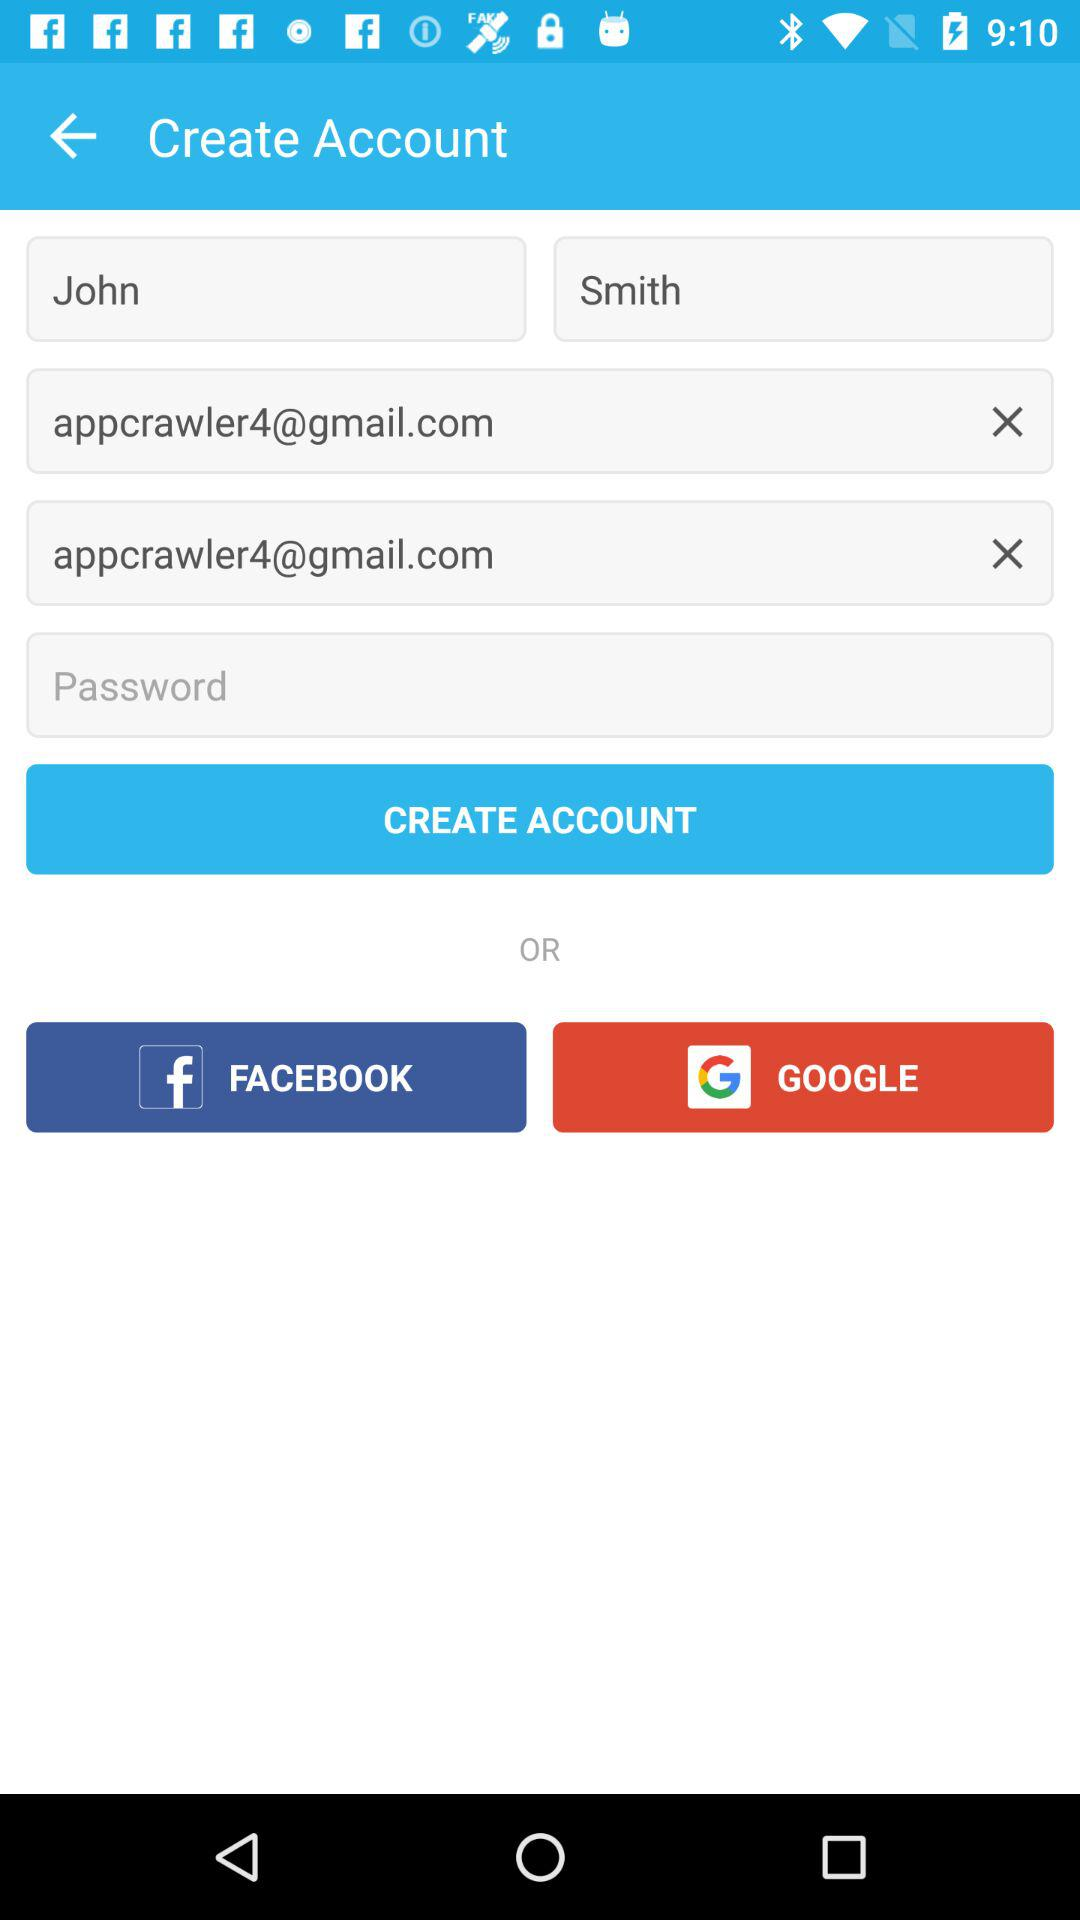What is the email address? The email address is appcrawler4@gmail.com. 